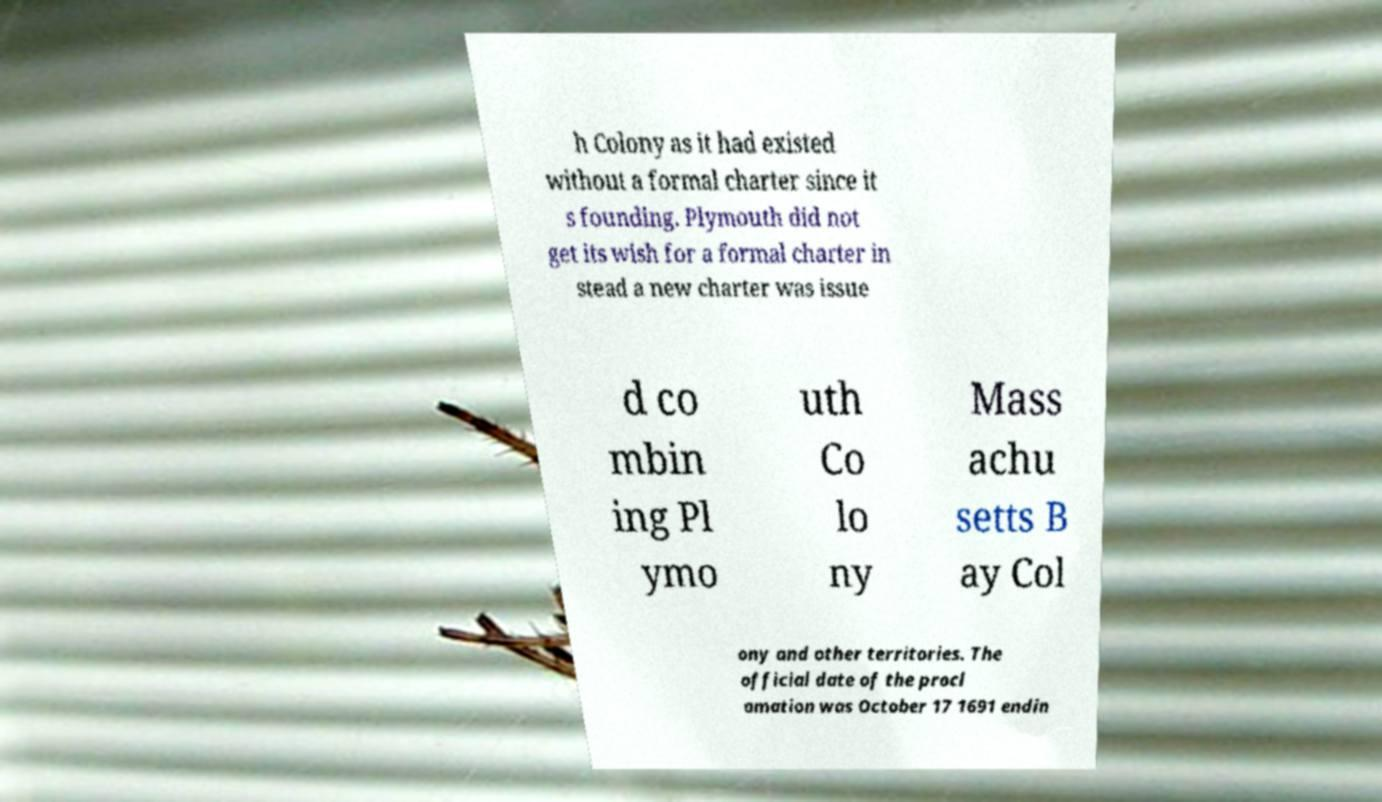I need the written content from this picture converted into text. Can you do that? h Colony as it had existed without a formal charter since it s founding. Plymouth did not get its wish for a formal charter in stead a new charter was issue d co mbin ing Pl ymo uth Co lo ny Mass achu setts B ay Col ony and other territories. The official date of the procl amation was October 17 1691 endin 